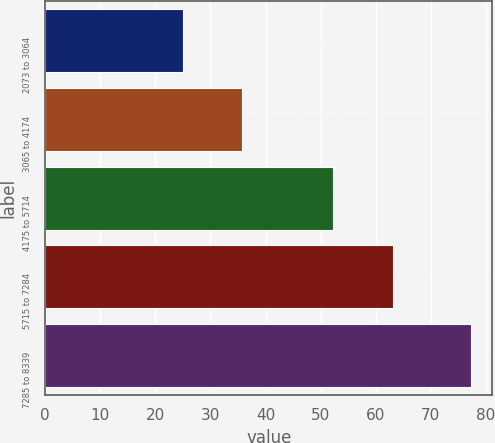<chart> <loc_0><loc_0><loc_500><loc_500><bar_chart><fcel>2073 to 3064<fcel>3065 to 4174<fcel>4175 to 5714<fcel>5715 to 7284<fcel>7285 to 8339<nl><fcel>24.94<fcel>35.78<fcel>52.17<fcel>63.17<fcel>77.28<nl></chart> 